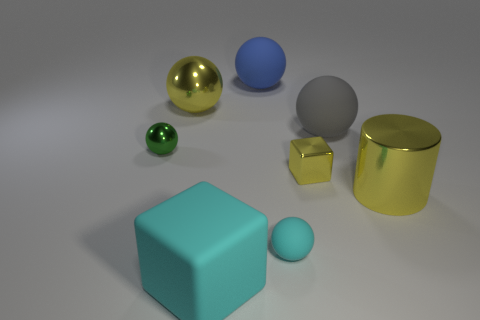There is a yellow object that is the same shape as the tiny green thing; what material is it?
Give a very brief answer. Metal. How many spheres are tiny objects or big purple objects?
Give a very brief answer. 2. How many big cyan objects have the same material as the gray ball?
Your response must be concise. 1. Is the block in front of the tiny yellow metallic cube made of the same material as the yellow cube in front of the green shiny object?
Make the answer very short. No. There is a small metal thing that is right of the yellow metallic sphere that is behind the gray rubber sphere; what number of cyan rubber spheres are behind it?
Give a very brief answer. 0. Does the big ball that is to the left of the big cyan matte thing have the same color as the cube that is to the right of the tiny rubber thing?
Keep it short and to the point. Yes. Are there any other things that are the same color as the tiny metal sphere?
Provide a succinct answer. No. What is the color of the big metal thing that is to the right of the large matte object in front of the gray thing?
Provide a succinct answer. Yellow. Is there a small green shiny thing?
Give a very brief answer. Yes. There is a sphere that is both left of the big block and behind the small green object; what color is it?
Make the answer very short. Yellow. 